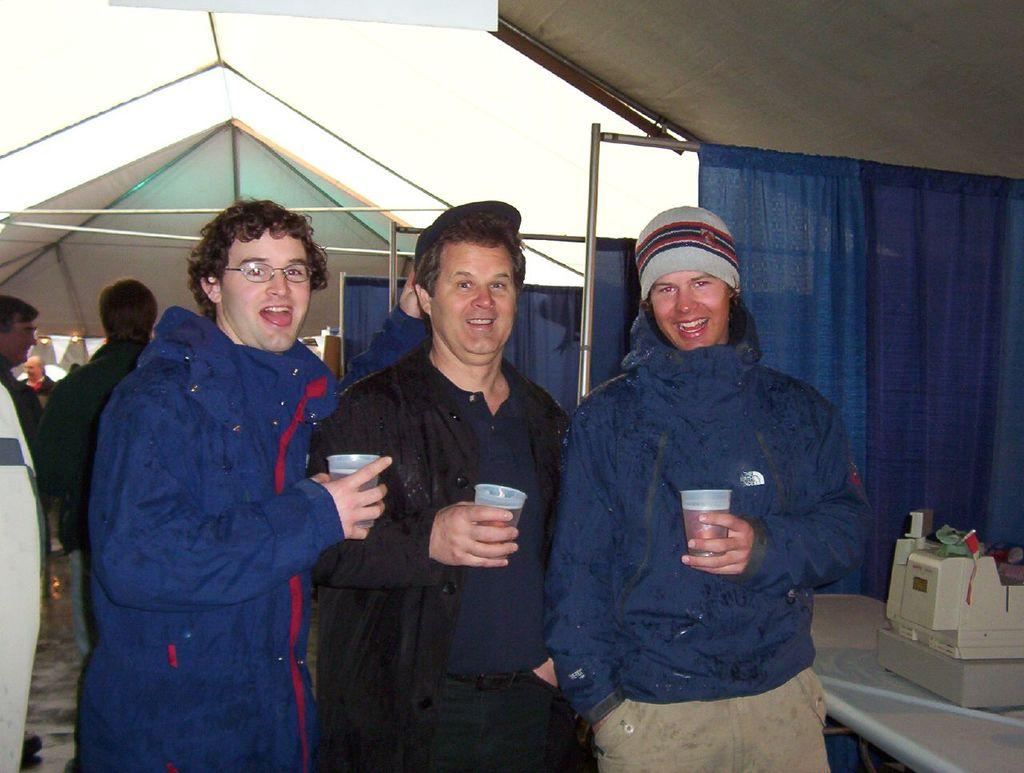How many people are present in the image? There are three people in the image. What are the people doing in the image? The people are standing and holding glasses. What can be seen above the people in the image? There is a roof visible in the image. What type of furniture is present in the image? There is a curtain with a stand and a table in the image. What is on the table in the image? There is a motor on a table in the image. What is visible beneath the people in the image? The floor is visible in the image. How many waves can be seen crashing on the shore in the image? There are no waves or shore visible in the image; it features three people standing and holding glasses. 